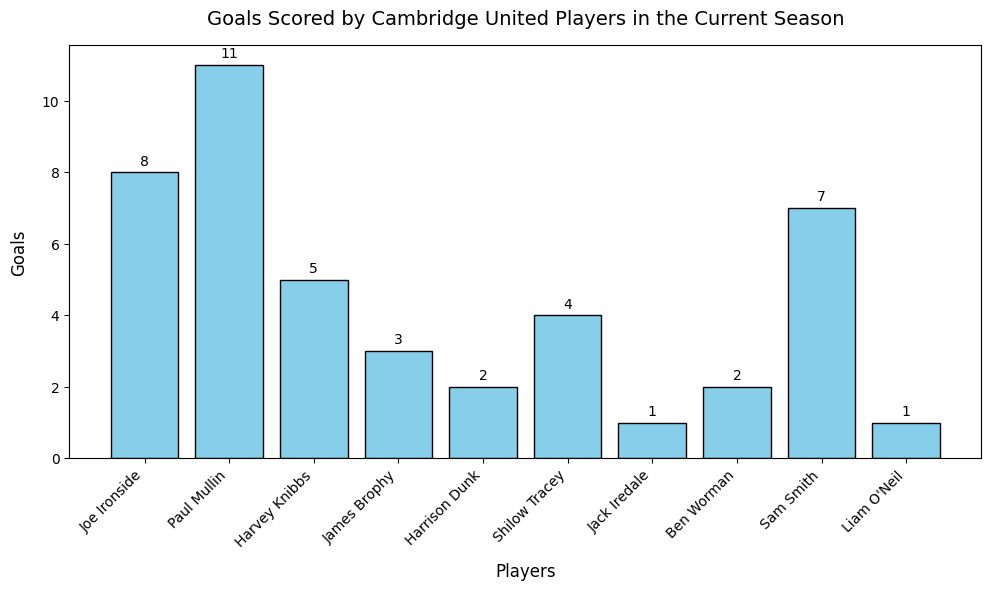What is the total number of goals scored by Cambridge United players in the current season? Sum up all the goals scored by each player: 8 (Joe Ironside) + 11 (Paul Mullin) + 5 (Harvey Knibbs) + 3 (James Brophy) + 2 (Harrison Dunk) + 4 (Shilow Tracey) + 1 (Jack Iredale) + 2 (Ben Worman) + 7 (Sam Smith) + 1 (Liam O'Neil) = 44
Answer: 44 Which player scored the most goals, and how many did they score? Find the tallest bar, which corresponds to the player with the most goals. Paul Mullin's bar is the tallest with 11 goals.
Answer: Paul Mullin, 11 Which player scored more goals, Joe Ironside or Sam Smith? Compare the heights (or numerical labels) of Joe Ironside's bar (8 goals) and Sam Smith's bar (7 goals). Joe Ironside scored more goals than Sam Smith.
Answer: Joe Ironside Who has scored the least goals among the players, and how many was it? Find the shortest bar, which corresponds to Jack Iredale and Liam O'Neil, each having scored 1 goal.
Answer: Jack Iredale and Liam O'Neil, 1 How many players scored more than 5 goals? Count the number of bars with heights greater than 5: Joe Ironside (8), Paul Mullin (11), and Sam Smith (7). There are 3 players.
Answer: 3 What is the difference in goals scored between Paul Mullin and Joe Ironside? Subtract the number of goals Joe Ironside scored (8) from Paul Mullin's 11 goals: 11 - 8 = 3
Answer: 3 Which players scored exactly 2 goals each? Identify the bars with a height of 2, which are Harrison Dunk and Ben Worman.
Answer: Harrison Dunk and Ben Worman What is the average number of goals scored by all players? Total goals scored is 44, divided by the number of players (10): 44 / 10 = 4.4
Answer: 4.4 Among the top three goal scorers, how many more goals did Paul Mullin score compared to Sam Smith? Identify top three scorers: Paul Mullin (11), Joe Ironside (8), and Sam Smith (7). Difference between Paul Mullin and Sam Smith is 11 - 7 = 4
Answer: 4 What is the sum of goals scored by Harvey Knibbs and Shilow Tracey? Add goals scored by Harvey Knibbs (5) and Shilow Tracey (4): 5 + 4 = 9
Answer: 9 